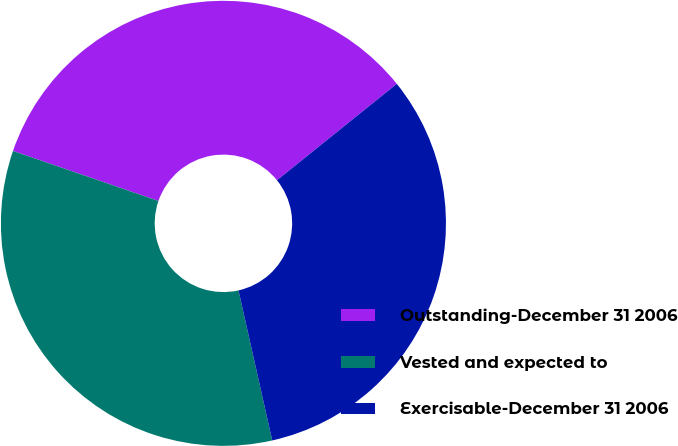Convert chart to OTSL. <chart><loc_0><loc_0><loc_500><loc_500><pie_chart><fcel>Outstanding-December 31 2006<fcel>Vested and expected to<fcel>Exercisable-December 31 2006<nl><fcel>33.94%<fcel>33.79%<fcel>32.26%<nl></chart> 